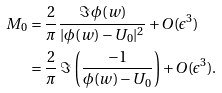Convert formula to latex. <formula><loc_0><loc_0><loc_500><loc_500>M _ { 0 } & = \frac { 2 } { \pi } \frac { \Im \, \phi ( w ) } { | \phi ( w ) - U _ { 0 } | ^ { 2 } } + O ( \epsilon ^ { 3 } ) \\ & = \frac { 2 } { \pi } \, \Im \, \left ( \frac { - 1 } { \phi ( w ) - U _ { 0 } } \right ) + O ( \epsilon ^ { 3 } ) .</formula> 